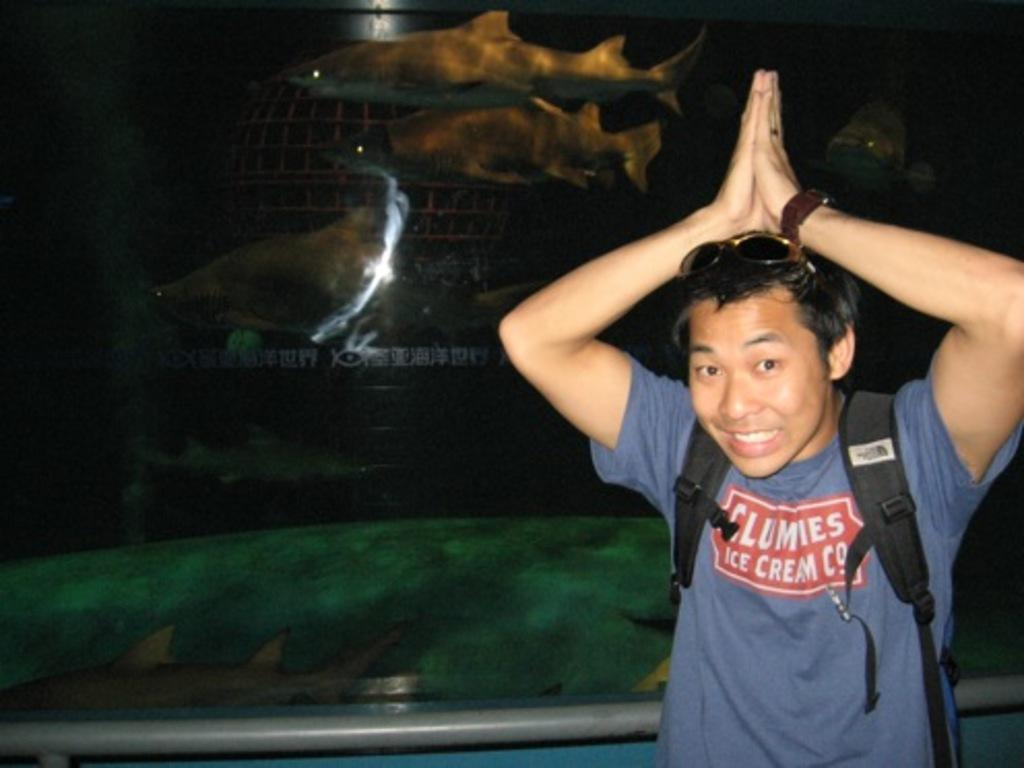Who is present in the image? There is a man in the image. What is the man doing in the image? The man is standing in the image. What expression does the man have in the image? The man is smiling in the image. What is visible behind the man? There is glass behind the man, and fishes are visible behind the glass. What type of sugar is being used to sweeten the week in the image? There is no mention of sugar or a week in the image; it features a man standing and smiling with glass and fishes behind him. 